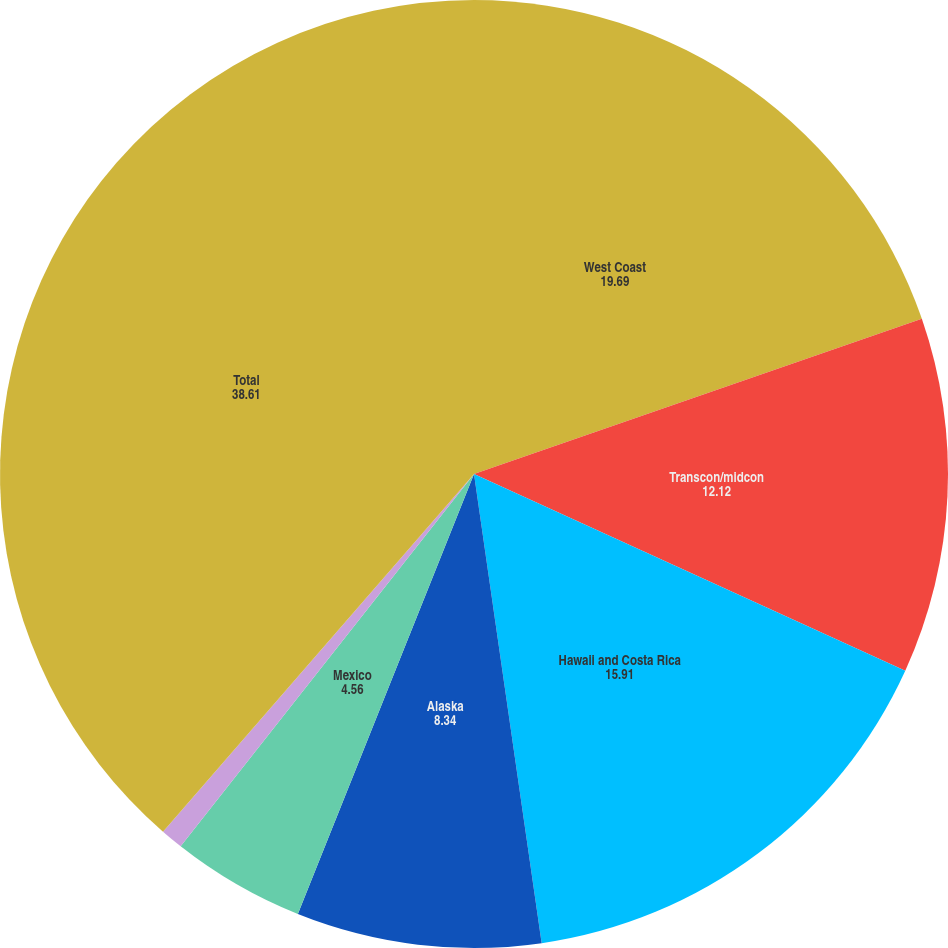Convert chart to OTSL. <chart><loc_0><loc_0><loc_500><loc_500><pie_chart><fcel>West Coast<fcel>Transcon/midcon<fcel>Hawaii and Costa Rica<fcel>Alaska<fcel>Mexico<fcel>Canada<fcel>Total<nl><fcel>19.69%<fcel>12.12%<fcel>15.91%<fcel>8.34%<fcel>4.56%<fcel>0.77%<fcel>38.61%<nl></chart> 